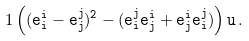Convert formula to latex. <formula><loc_0><loc_0><loc_500><loc_500>1 \tt \left ( ( e _ { i } ^ { i } - e _ { j } ^ { j } ) ^ { 2 } - ( e _ { i } ^ { j } e _ { j } ^ { i } + e _ { j } ^ { i } e _ { i } ^ { j } ) \right ) u \, .</formula> 